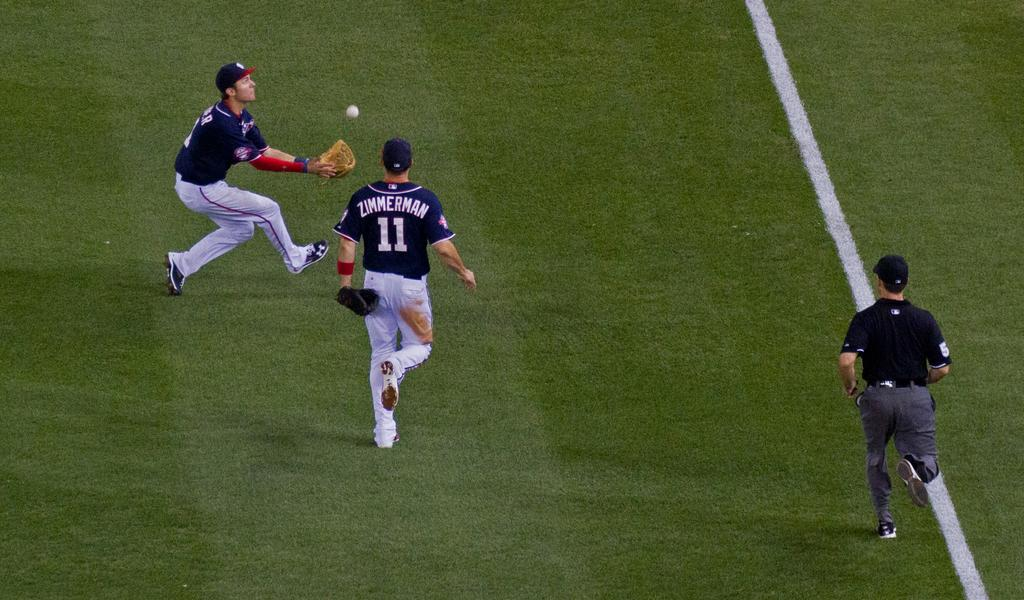<image>
Share a concise interpretation of the image provided. A player named Zimmerman races toward another player, who is catching the ball. 